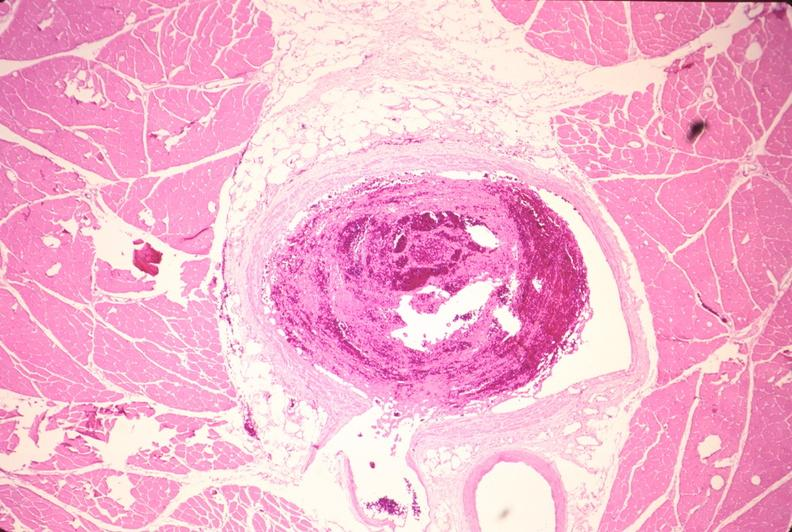what does this image show?
Answer the question using a single word or phrase. Leg veins 